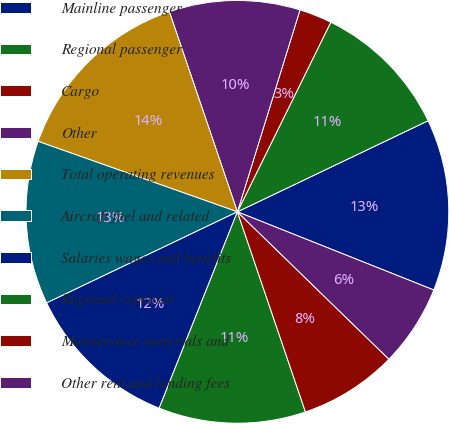<chart> <loc_0><loc_0><loc_500><loc_500><pie_chart><fcel>Mainline passenger<fcel>Regional passenger<fcel>Cargo<fcel>Other<fcel>Total operating revenues<fcel>Aircraft fuel and related<fcel>Salaries wages and benefits<fcel>Regional expenses<fcel>Maintenance materials and<fcel>Other rent and landing fees<nl><fcel>13.12%<fcel>10.62%<fcel>2.5%<fcel>10.0%<fcel>14.37%<fcel>12.5%<fcel>11.87%<fcel>11.25%<fcel>7.5%<fcel>6.25%<nl></chart> 